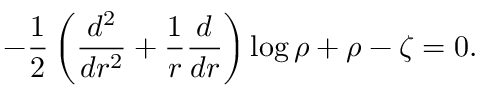<formula> <loc_0><loc_0><loc_500><loc_500>- \frac { 1 } { 2 } \left ( \frac { d ^ { 2 } } { d r ^ { 2 } } + \frac { 1 } { r } \frac { d } d r } \right ) \log \rho + \rho - \zeta = 0 .</formula> 